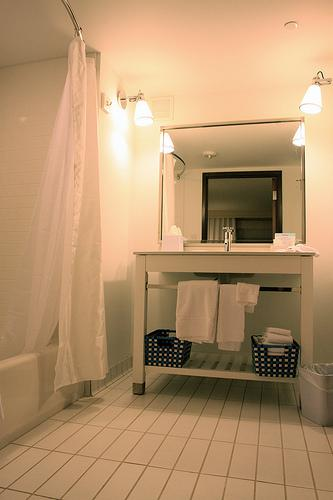Question: what is on the counter?
Choices:
A. A bottle of soap.
B. A sponge.
C. A rag.
D. A tissue box.
Answer with the letter. Answer: D Question: why are there towels?
Choices:
A. To dry your face.
B. To dry your arms.
C. To dry your feet.
D. To dry your hands.
Answer with the letter. Answer: D Question: what is under the sink?
Choices:
A. Baskets.
B. Cleaning supplies.
C. Jars.
D. Cups.
Answer with the letter. Answer: A Question: how many baskets are there?
Choices:
A. Two.
B. Three.
C. Four.
D. Five.
Answer with the letter. Answer: A Question: what color are the floor tiles?
Choices:
A. Black.
B. White.
C. Blue.
D. Green.
Answer with the letter. Answer: B Question: where is the mirror?
Choices:
A. Hanging above the bed.
B. Hanging above the chair.
C. Hanging above the sink.
D. Hanging above the fireplace.
Answer with the letter. Answer: C 